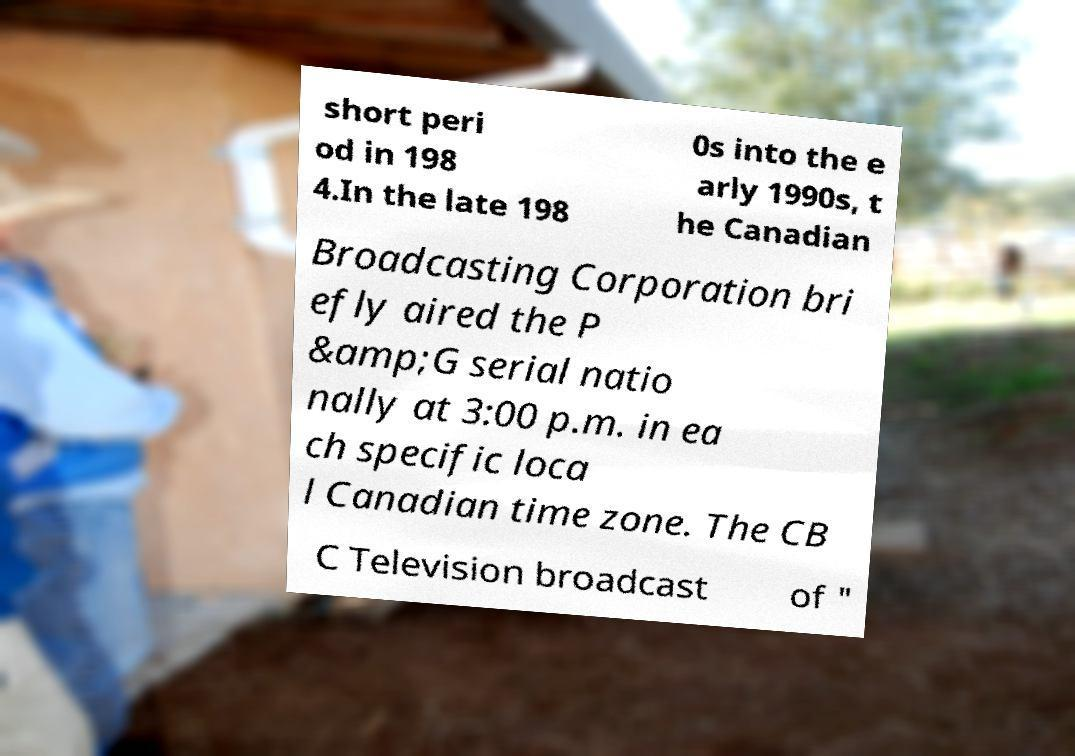I need the written content from this picture converted into text. Can you do that? short peri od in 198 4.In the late 198 0s into the e arly 1990s, t he Canadian Broadcasting Corporation bri efly aired the P &amp;G serial natio nally at 3:00 p.m. in ea ch specific loca l Canadian time zone. The CB C Television broadcast of " 